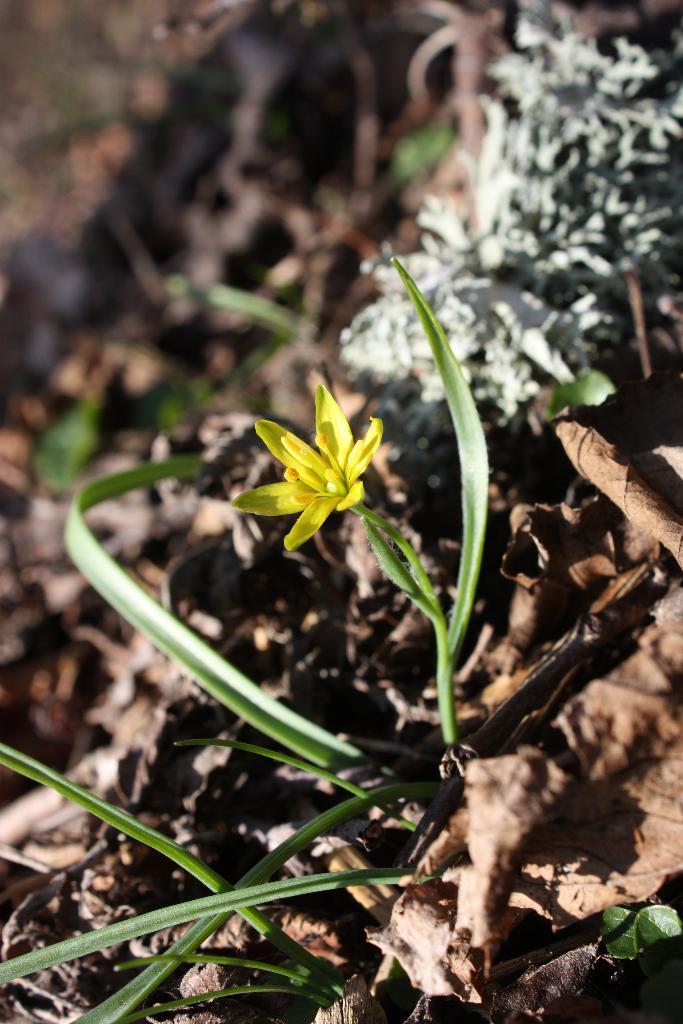How would you summarize this image in a sentence or two? In the image in the center, we can see dry leaves, plants and one flower, which is in yellow color. 